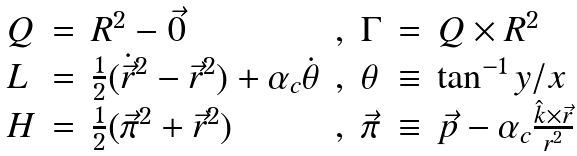Convert formula to latex. <formula><loc_0><loc_0><loc_500><loc_500>\begin{array} { l c l c l c l } Q & = & R ^ { 2 } - \vec { 0 } & , & \Gamma & = & Q \times R ^ { 2 } \\ L & = & \frac { 1 } { 2 } ( \dot { \vec { r } } ^ { 2 } - \vec { r } ^ { 2 } ) + \alpha _ { c } \dot { \theta } & , & \theta & \equiv & \tan ^ { - 1 } { y / x } \\ H & = & \frac { 1 } { 2 } ( \vec { \pi } ^ { 2 } + \vec { r } ^ { 2 } ) & , & \vec { \pi } & \equiv & \vec { p } - \alpha _ { c } \frac { \hat { k } \times \vec { r } } { r ^ { 2 } } \end{array}</formula> 